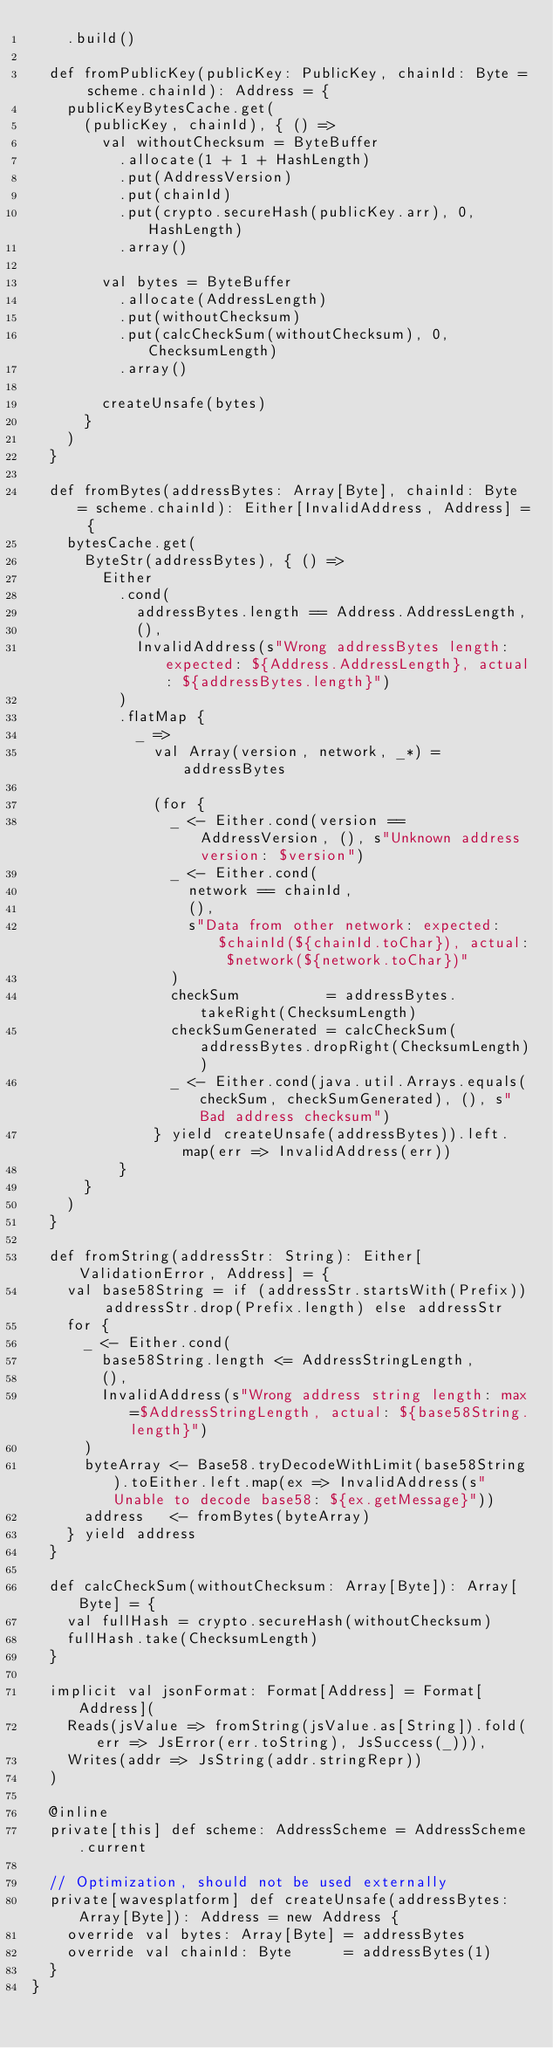Convert code to text. <code><loc_0><loc_0><loc_500><loc_500><_Scala_>    .build()

  def fromPublicKey(publicKey: PublicKey, chainId: Byte = scheme.chainId): Address = {
    publicKeyBytesCache.get(
      (publicKey, chainId), { () =>
        val withoutChecksum = ByteBuffer
          .allocate(1 + 1 + HashLength)
          .put(AddressVersion)
          .put(chainId)
          .put(crypto.secureHash(publicKey.arr), 0, HashLength)
          .array()

        val bytes = ByteBuffer
          .allocate(AddressLength)
          .put(withoutChecksum)
          .put(calcCheckSum(withoutChecksum), 0, ChecksumLength)
          .array()

        createUnsafe(bytes)
      }
    )
  }

  def fromBytes(addressBytes: Array[Byte], chainId: Byte = scheme.chainId): Either[InvalidAddress, Address] = {
    bytesCache.get(
      ByteStr(addressBytes), { () =>
        Either
          .cond(
            addressBytes.length == Address.AddressLength,
            (),
            InvalidAddress(s"Wrong addressBytes length: expected: ${Address.AddressLength}, actual: ${addressBytes.length}")
          )
          .flatMap {
            _ =>
              val Array(version, network, _*) = addressBytes

              (for {
                _ <- Either.cond(version == AddressVersion, (), s"Unknown address version: $version")
                _ <- Either.cond(
                  network == chainId,
                  (),
                  s"Data from other network: expected: $chainId(${chainId.toChar}), actual: $network(${network.toChar})"
                )
                checkSum          = addressBytes.takeRight(ChecksumLength)
                checkSumGenerated = calcCheckSum(addressBytes.dropRight(ChecksumLength))
                _ <- Either.cond(java.util.Arrays.equals(checkSum, checkSumGenerated), (), s"Bad address checksum")
              } yield createUnsafe(addressBytes)).left.map(err => InvalidAddress(err))
          }
      }
    )
  }

  def fromString(addressStr: String): Either[ValidationError, Address] = {
    val base58String = if (addressStr.startsWith(Prefix)) addressStr.drop(Prefix.length) else addressStr
    for {
      _ <- Either.cond(
        base58String.length <= AddressStringLength,
        (),
        InvalidAddress(s"Wrong address string length: max=$AddressStringLength, actual: ${base58String.length}")
      )
      byteArray <- Base58.tryDecodeWithLimit(base58String).toEither.left.map(ex => InvalidAddress(s"Unable to decode base58: ${ex.getMessage}"))
      address   <- fromBytes(byteArray)
    } yield address
  }

  def calcCheckSum(withoutChecksum: Array[Byte]): Array[Byte] = {
    val fullHash = crypto.secureHash(withoutChecksum)
    fullHash.take(ChecksumLength)
  }

  implicit val jsonFormat: Format[Address] = Format[Address](
    Reads(jsValue => fromString(jsValue.as[String]).fold(err => JsError(err.toString), JsSuccess(_))),
    Writes(addr => JsString(addr.stringRepr))
  )

  @inline
  private[this] def scheme: AddressScheme = AddressScheme.current

  // Optimization, should not be used externally
  private[wavesplatform] def createUnsafe(addressBytes: Array[Byte]): Address = new Address {
    override val bytes: Array[Byte] = addressBytes
    override val chainId: Byte      = addressBytes(1)
  }
}
</code> 